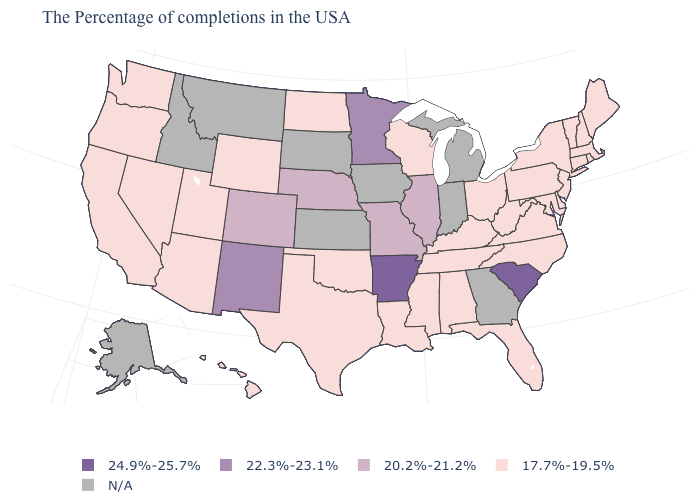Does South Carolina have the highest value in the USA?
Write a very short answer. Yes. Name the states that have a value in the range 20.2%-21.2%?
Write a very short answer. Illinois, Missouri, Nebraska, Colorado. Among the states that border Rhode Island , which have the highest value?
Concise answer only. Massachusetts, Connecticut. Does Ohio have the lowest value in the MidWest?
Answer briefly. Yes. Among the states that border Nebraska , does Wyoming have the lowest value?
Quick response, please. Yes. Among the states that border West Virginia , which have the lowest value?
Answer briefly. Maryland, Pennsylvania, Virginia, Ohio, Kentucky. Name the states that have a value in the range 24.9%-25.7%?
Short answer required. South Carolina, Arkansas. Does the map have missing data?
Concise answer only. Yes. Does New Mexico have the highest value in the West?
Quick response, please. Yes. Does Wyoming have the lowest value in the West?
Give a very brief answer. Yes. What is the highest value in the USA?
Be succinct. 24.9%-25.7%. Among the states that border New Mexico , does Colorado have the lowest value?
Give a very brief answer. No. Name the states that have a value in the range N/A?
Concise answer only. Georgia, Michigan, Indiana, Iowa, Kansas, South Dakota, Montana, Idaho, Alaska. Name the states that have a value in the range 20.2%-21.2%?
Give a very brief answer. Illinois, Missouri, Nebraska, Colorado. Does the map have missing data?
Give a very brief answer. Yes. 